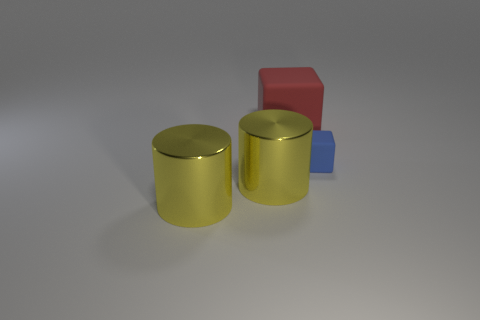What is the color of the large object that is behind the matte object in front of the cube that is on the left side of the small cube?
Keep it short and to the point. Red. There is a big red rubber cube behind the small cube; is there a large red matte thing to the right of it?
Provide a succinct answer. No. Is the color of the rubber block in front of the large red cube the same as the cube that is on the left side of the small thing?
Provide a succinct answer. No. How many metallic cylinders have the same size as the red thing?
Offer a terse response. 2. There is a thing that is on the right side of the red object; is its size the same as the large rubber object?
Give a very brief answer. No. The tiny blue rubber thing is what shape?
Provide a short and direct response. Cube. Do the cube in front of the large matte thing and the large cube have the same material?
Offer a terse response. Yes. Are there any other small cubes of the same color as the small cube?
Your response must be concise. No. There is a matte thing that is to the left of the small blue thing; is it the same shape as the matte object in front of the red matte thing?
Provide a short and direct response. Yes. Are there any other objects that have the same material as the small blue object?
Your answer should be compact. Yes. 